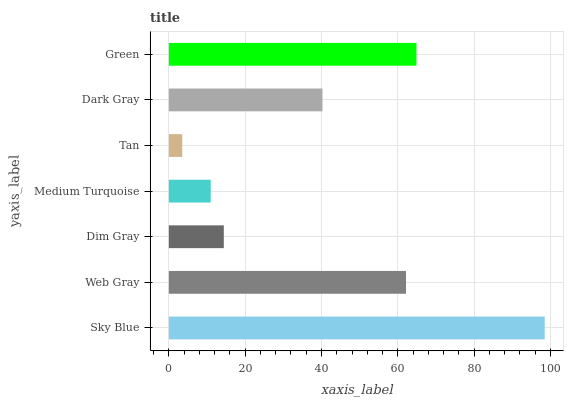Is Tan the minimum?
Answer yes or no. Yes. Is Sky Blue the maximum?
Answer yes or no. Yes. Is Web Gray the minimum?
Answer yes or no. No. Is Web Gray the maximum?
Answer yes or no. No. Is Sky Blue greater than Web Gray?
Answer yes or no. Yes. Is Web Gray less than Sky Blue?
Answer yes or no. Yes. Is Web Gray greater than Sky Blue?
Answer yes or no. No. Is Sky Blue less than Web Gray?
Answer yes or no. No. Is Dark Gray the high median?
Answer yes or no. Yes. Is Dark Gray the low median?
Answer yes or no. Yes. Is Green the high median?
Answer yes or no. No. Is Web Gray the low median?
Answer yes or no. No. 